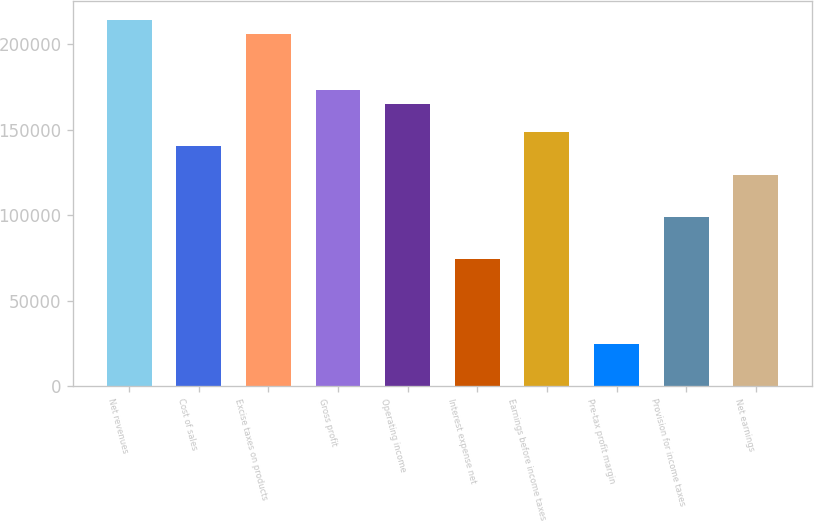Convert chart to OTSL. <chart><loc_0><loc_0><loc_500><loc_500><bar_chart><fcel>Net revenues<fcel>Cost of sales<fcel>Excise taxes on products<fcel>Gross profit<fcel>Operating income<fcel>Interest expense net<fcel>Earnings before income taxes<fcel>Pre-tax profit margin<fcel>Provision for income taxes<fcel>Net earnings<nl><fcel>214494<fcel>140247<fcel>206244<fcel>173246<fcel>164996<fcel>74250.4<fcel>148497<fcel>24752.7<fcel>98999.2<fcel>123748<nl></chart> 